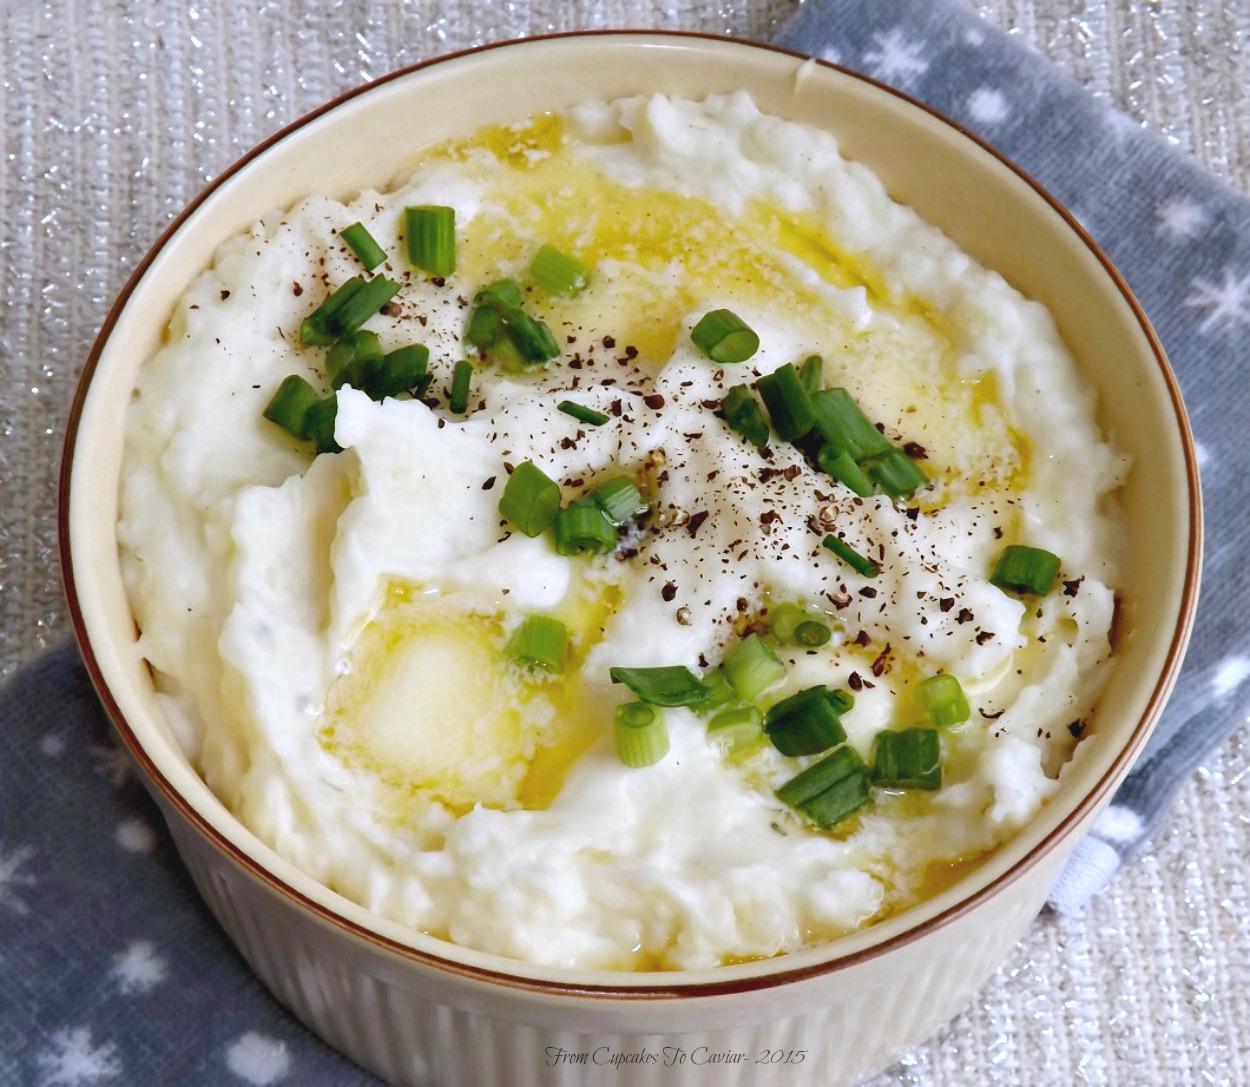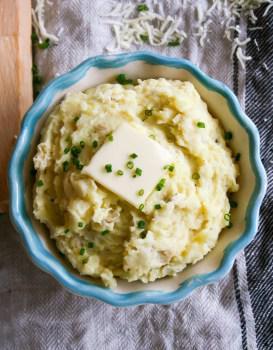The first image is the image on the left, the second image is the image on the right. Analyze the images presented: Is the assertion "One piece of silverware is in a dish that contains something resembling mashed potatoes." valid? Answer yes or no. No. The first image is the image on the left, the second image is the image on the right. Assess this claim about the two images: "There is a utensil adjacent to the mashed potatoes.". Correct or not? Answer yes or no. No. 